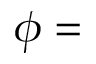Convert formula to latex. <formula><loc_0><loc_0><loc_500><loc_500>\phi =</formula> 